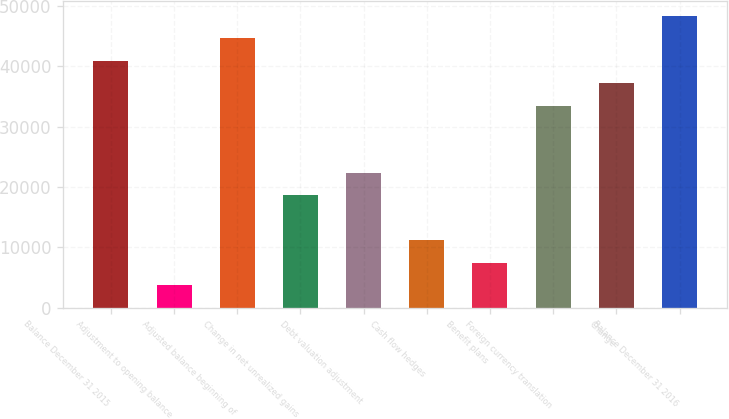<chart> <loc_0><loc_0><loc_500><loc_500><bar_chart><fcel>Balance December 31 2015<fcel>Adjustment to opening balance<fcel>Adjusted balance beginning of<fcel>Change in net unrealized gains<fcel>Debt valuation adjustment<fcel>Cash flow hedges<fcel>Benefit plans<fcel>Foreign currency translation<fcel>Change<fcel>Balance December 31 2016<nl><fcel>40886.7<fcel>3719.7<fcel>44603.4<fcel>18586.5<fcel>22303.2<fcel>11153.1<fcel>7436.4<fcel>33453.3<fcel>37170<fcel>48320.1<nl></chart> 